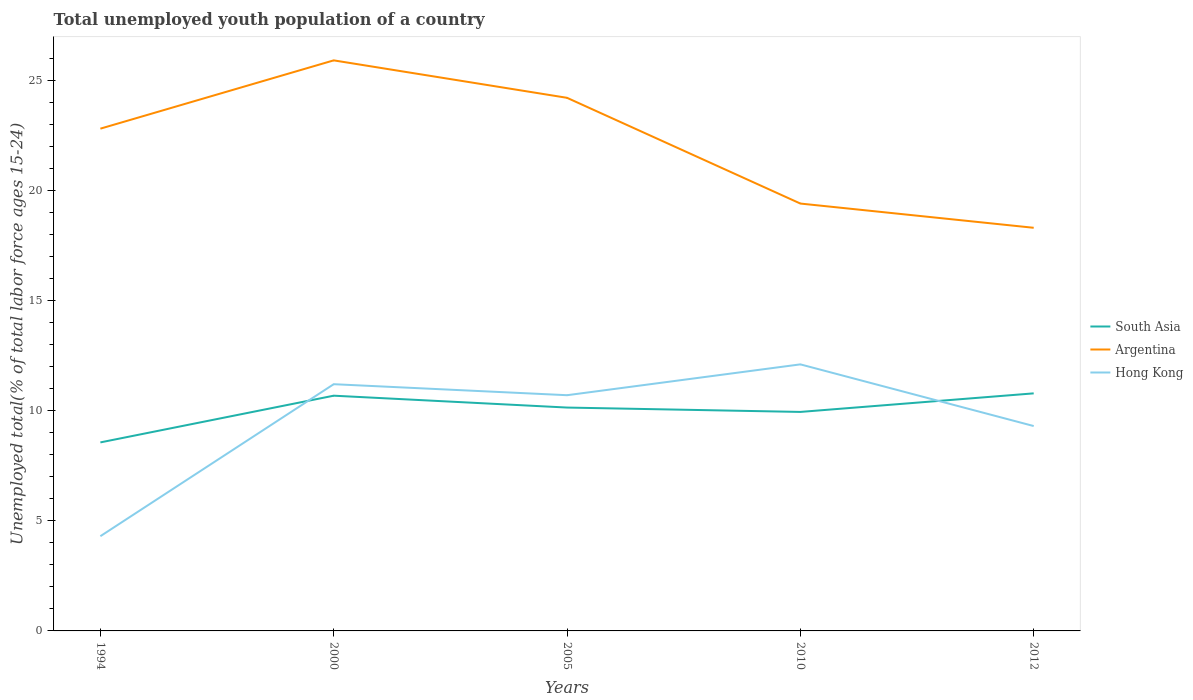Across all years, what is the maximum percentage of total unemployed youth population of a country in South Asia?
Give a very brief answer. 8.56. What is the total percentage of total unemployed youth population of a country in South Asia in the graph?
Make the answer very short. -0.11. What is the difference between the highest and the second highest percentage of total unemployed youth population of a country in Argentina?
Make the answer very short. 7.6. What is the difference between two consecutive major ticks on the Y-axis?
Your response must be concise. 5. Are the values on the major ticks of Y-axis written in scientific E-notation?
Ensure brevity in your answer.  No. Does the graph contain any zero values?
Offer a very short reply. No. What is the title of the graph?
Your answer should be very brief. Total unemployed youth population of a country. Does "Marshall Islands" appear as one of the legend labels in the graph?
Provide a short and direct response. No. What is the label or title of the Y-axis?
Your answer should be compact. Unemployed total(% of total labor force ages 15-24). What is the Unemployed total(% of total labor force ages 15-24) in South Asia in 1994?
Offer a very short reply. 8.56. What is the Unemployed total(% of total labor force ages 15-24) of Argentina in 1994?
Your answer should be compact. 22.8. What is the Unemployed total(% of total labor force ages 15-24) in Hong Kong in 1994?
Provide a succinct answer. 4.3. What is the Unemployed total(% of total labor force ages 15-24) of South Asia in 2000?
Provide a short and direct response. 10.68. What is the Unemployed total(% of total labor force ages 15-24) in Argentina in 2000?
Keep it short and to the point. 25.9. What is the Unemployed total(% of total labor force ages 15-24) of Hong Kong in 2000?
Your response must be concise. 11.2. What is the Unemployed total(% of total labor force ages 15-24) of South Asia in 2005?
Your response must be concise. 10.14. What is the Unemployed total(% of total labor force ages 15-24) of Argentina in 2005?
Ensure brevity in your answer.  24.2. What is the Unemployed total(% of total labor force ages 15-24) in Hong Kong in 2005?
Ensure brevity in your answer.  10.7. What is the Unemployed total(% of total labor force ages 15-24) in South Asia in 2010?
Offer a terse response. 9.94. What is the Unemployed total(% of total labor force ages 15-24) of Argentina in 2010?
Keep it short and to the point. 19.4. What is the Unemployed total(% of total labor force ages 15-24) of Hong Kong in 2010?
Offer a terse response. 12.1. What is the Unemployed total(% of total labor force ages 15-24) of South Asia in 2012?
Offer a very short reply. 10.78. What is the Unemployed total(% of total labor force ages 15-24) in Argentina in 2012?
Your answer should be compact. 18.3. What is the Unemployed total(% of total labor force ages 15-24) of Hong Kong in 2012?
Offer a terse response. 9.3. Across all years, what is the maximum Unemployed total(% of total labor force ages 15-24) in South Asia?
Offer a terse response. 10.78. Across all years, what is the maximum Unemployed total(% of total labor force ages 15-24) in Argentina?
Give a very brief answer. 25.9. Across all years, what is the maximum Unemployed total(% of total labor force ages 15-24) in Hong Kong?
Offer a terse response. 12.1. Across all years, what is the minimum Unemployed total(% of total labor force ages 15-24) in South Asia?
Offer a very short reply. 8.56. Across all years, what is the minimum Unemployed total(% of total labor force ages 15-24) of Argentina?
Keep it short and to the point. 18.3. Across all years, what is the minimum Unemployed total(% of total labor force ages 15-24) of Hong Kong?
Keep it short and to the point. 4.3. What is the total Unemployed total(% of total labor force ages 15-24) of South Asia in the graph?
Keep it short and to the point. 50.1. What is the total Unemployed total(% of total labor force ages 15-24) in Argentina in the graph?
Offer a very short reply. 110.6. What is the total Unemployed total(% of total labor force ages 15-24) of Hong Kong in the graph?
Give a very brief answer. 47.6. What is the difference between the Unemployed total(% of total labor force ages 15-24) of South Asia in 1994 and that in 2000?
Offer a very short reply. -2.12. What is the difference between the Unemployed total(% of total labor force ages 15-24) in South Asia in 1994 and that in 2005?
Ensure brevity in your answer.  -1.58. What is the difference between the Unemployed total(% of total labor force ages 15-24) of Argentina in 1994 and that in 2005?
Your response must be concise. -1.4. What is the difference between the Unemployed total(% of total labor force ages 15-24) in Hong Kong in 1994 and that in 2005?
Your answer should be very brief. -6.4. What is the difference between the Unemployed total(% of total labor force ages 15-24) of South Asia in 1994 and that in 2010?
Your answer should be compact. -1.38. What is the difference between the Unemployed total(% of total labor force ages 15-24) of Argentina in 1994 and that in 2010?
Make the answer very short. 3.4. What is the difference between the Unemployed total(% of total labor force ages 15-24) of South Asia in 1994 and that in 2012?
Your answer should be compact. -2.23. What is the difference between the Unemployed total(% of total labor force ages 15-24) in Hong Kong in 1994 and that in 2012?
Offer a very short reply. -5. What is the difference between the Unemployed total(% of total labor force ages 15-24) of South Asia in 2000 and that in 2005?
Your answer should be very brief. 0.54. What is the difference between the Unemployed total(% of total labor force ages 15-24) in Argentina in 2000 and that in 2005?
Provide a succinct answer. 1.7. What is the difference between the Unemployed total(% of total labor force ages 15-24) in Hong Kong in 2000 and that in 2005?
Offer a terse response. 0.5. What is the difference between the Unemployed total(% of total labor force ages 15-24) of South Asia in 2000 and that in 2010?
Provide a succinct answer. 0.74. What is the difference between the Unemployed total(% of total labor force ages 15-24) of South Asia in 2000 and that in 2012?
Your answer should be very brief. -0.11. What is the difference between the Unemployed total(% of total labor force ages 15-24) in Argentina in 2000 and that in 2012?
Provide a short and direct response. 7.6. What is the difference between the Unemployed total(% of total labor force ages 15-24) in South Asia in 2005 and that in 2010?
Offer a terse response. 0.2. What is the difference between the Unemployed total(% of total labor force ages 15-24) of South Asia in 2005 and that in 2012?
Your answer should be compact. -0.64. What is the difference between the Unemployed total(% of total labor force ages 15-24) of Argentina in 2005 and that in 2012?
Keep it short and to the point. 5.9. What is the difference between the Unemployed total(% of total labor force ages 15-24) in Hong Kong in 2005 and that in 2012?
Offer a terse response. 1.4. What is the difference between the Unemployed total(% of total labor force ages 15-24) in South Asia in 2010 and that in 2012?
Your response must be concise. -0.84. What is the difference between the Unemployed total(% of total labor force ages 15-24) in South Asia in 1994 and the Unemployed total(% of total labor force ages 15-24) in Argentina in 2000?
Ensure brevity in your answer.  -17.34. What is the difference between the Unemployed total(% of total labor force ages 15-24) of South Asia in 1994 and the Unemployed total(% of total labor force ages 15-24) of Hong Kong in 2000?
Make the answer very short. -2.64. What is the difference between the Unemployed total(% of total labor force ages 15-24) of South Asia in 1994 and the Unemployed total(% of total labor force ages 15-24) of Argentina in 2005?
Provide a succinct answer. -15.64. What is the difference between the Unemployed total(% of total labor force ages 15-24) of South Asia in 1994 and the Unemployed total(% of total labor force ages 15-24) of Hong Kong in 2005?
Your answer should be very brief. -2.14. What is the difference between the Unemployed total(% of total labor force ages 15-24) of Argentina in 1994 and the Unemployed total(% of total labor force ages 15-24) of Hong Kong in 2005?
Offer a very short reply. 12.1. What is the difference between the Unemployed total(% of total labor force ages 15-24) in South Asia in 1994 and the Unemployed total(% of total labor force ages 15-24) in Argentina in 2010?
Keep it short and to the point. -10.84. What is the difference between the Unemployed total(% of total labor force ages 15-24) in South Asia in 1994 and the Unemployed total(% of total labor force ages 15-24) in Hong Kong in 2010?
Offer a very short reply. -3.54. What is the difference between the Unemployed total(% of total labor force ages 15-24) of Argentina in 1994 and the Unemployed total(% of total labor force ages 15-24) of Hong Kong in 2010?
Make the answer very short. 10.7. What is the difference between the Unemployed total(% of total labor force ages 15-24) in South Asia in 1994 and the Unemployed total(% of total labor force ages 15-24) in Argentina in 2012?
Provide a short and direct response. -9.74. What is the difference between the Unemployed total(% of total labor force ages 15-24) in South Asia in 1994 and the Unemployed total(% of total labor force ages 15-24) in Hong Kong in 2012?
Provide a short and direct response. -0.74. What is the difference between the Unemployed total(% of total labor force ages 15-24) in South Asia in 2000 and the Unemployed total(% of total labor force ages 15-24) in Argentina in 2005?
Make the answer very short. -13.52. What is the difference between the Unemployed total(% of total labor force ages 15-24) in South Asia in 2000 and the Unemployed total(% of total labor force ages 15-24) in Hong Kong in 2005?
Offer a terse response. -0.02. What is the difference between the Unemployed total(% of total labor force ages 15-24) in South Asia in 2000 and the Unemployed total(% of total labor force ages 15-24) in Argentina in 2010?
Provide a succinct answer. -8.72. What is the difference between the Unemployed total(% of total labor force ages 15-24) of South Asia in 2000 and the Unemployed total(% of total labor force ages 15-24) of Hong Kong in 2010?
Keep it short and to the point. -1.42. What is the difference between the Unemployed total(% of total labor force ages 15-24) in South Asia in 2000 and the Unemployed total(% of total labor force ages 15-24) in Argentina in 2012?
Ensure brevity in your answer.  -7.62. What is the difference between the Unemployed total(% of total labor force ages 15-24) in South Asia in 2000 and the Unemployed total(% of total labor force ages 15-24) in Hong Kong in 2012?
Provide a succinct answer. 1.38. What is the difference between the Unemployed total(% of total labor force ages 15-24) of Argentina in 2000 and the Unemployed total(% of total labor force ages 15-24) of Hong Kong in 2012?
Your answer should be compact. 16.6. What is the difference between the Unemployed total(% of total labor force ages 15-24) in South Asia in 2005 and the Unemployed total(% of total labor force ages 15-24) in Argentina in 2010?
Keep it short and to the point. -9.26. What is the difference between the Unemployed total(% of total labor force ages 15-24) of South Asia in 2005 and the Unemployed total(% of total labor force ages 15-24) of Hong Kong in 2010?
Offer a very short reply. -1.96. What is the difference between the Unemployed total(% of total labor force ages 15-24) of Argentina in 2005 and the Unemployed total(% of total labor force ages 15-24) of Hong Kong in 2010?
Keep it short and to the point. 12.1. What is the difference between the Unemployed total(% of total labor force ages 15-24) in South Asia in 2005 and the Unemployed total(% of total labor force ages 15-24) in Argentina in 2012?
Give a very brief answer. -8.16. What is the difference between the Unemployed total(% of total labor force ages 15-24) of South Asia in 2005 and the Unemployed total(% of total labor force ages 15-24) of Hong Kong in 2012?
Offer a very short reply. 0.84. What is the difference between the Unemployed total(% of total labor force ages 15-24) of South Asia in 2010 and the Unemployed total(% of total labor force ages 15-24) of Argentina in 2012?
Ensure brevity in your answer.  -8.36. What is the difference between the Unemployed total(% of total labor force ages 15-24) in South Asia in 2010 and the Unemployed total(% of total labor force ages 15-24) in Hong Kong in 2012?
Keep it short and to the point. 0.64. What is the average Unemployed total(% of total labor force ages 15-24) of South Asia per year?
Keep it short and to the point. 10.02. What is the average Unemployed total(% of total labor force ages 15-24) of Argentina per year?
Your answer should be very brief. 22.12. What is the average Unemployed total(% of total labor force ages 15-24) of Hong Kong per year?
Provide a succinct answer. 9.52. In the year 1994, what is the difference between the Unemployed total(% of total labor force ages 15-24) in South Asia and Unemployed total(% of total labor force ages 15-24) in Argentina?
Your answer should be very brief. -14.24. In the year 1994, what is the difference between the Unemployed total(% of total labor force ages 15-24) of South Asia and Unemployed total(% of total labor force ages 15-24) of Hong Kong?
Make the answer very short. 4.26. In the year 1994, what is the difference between the Unemployed total(% of total labor force ages 15-24) in Argentina and Unemployed total(% of total labor force ages 15-24) in Hong Kong?
Give a very brief answer. 18.5. In the year 2000, what is the difference between the Unemployed total(% of total labor force ages 15-24) in South Asia and Unemployed total(% of total labor force ages 15-24) in Argentina?
Offer a very short reply. -15.22. In the year 2000, what is the difference between the Unemployed total(% of total labor force ages 15-24) of South Asia and Unemployed total(% of total labor force ages 15-24) of Hong Kong?
Your answer should be compact. -0.52. In the year 2005, what is the difference between the Unemployed total(% of total labor force ages 15-24) of South Asia and Unemployed total(% of total labor force ages 15-24) of Argentina?
Make the answer very short. -14.06. In the year 2005, what is the difference between the Unemployed total(% of total labor force ages 15-24) of South Asia and Unemployed total(% of total labor force ages 15-24) of Hong Kong?
Keep it short and to the point. -0.56. In the year 2005, what is the difference between the Unemployed total(% of total labor force ages 15-24) in Argentina and Unemployed total(% of total labor force ages 15-24) in Hong Kong?
Provide a succinct answer. 13.5. In the year 2010, what is the difference between the Unemployed total(% of total labor force ages 15-24) in South Asia and Unemployed total(% of total labor force ages 15-24) in Argentina?
Make the answer very short. -9.46. In the year 2010, what is the difference between the Unemployed total(% of total labor force ages 15-24) of South Asia and Unemployed total(% of total labor force ages 15-24) of Hong Kong?
Provide a succinct answer. -2.16. In the year 2010, what is the difference between the Unemployed total(% of total labor force ages 15-24) in Argentina and Unemployed total(% of total labor force ages 15-24) in Hong Kong?
Offer a very short reply. 7.3. In the year 2012, what is the difference between the Unemployed total(% of total labor force ages 15-24) in South Asia and Unemployed total(% of total labor force ages 15-24) in Argentina?
Ensure brevity in your answer.  -7.52. In the year 2012, what is the difference between the Unemployed total(% of total labor force ages 15-24) in South Asia and Unemployed total(% of total labor force ages 15-24) in Hong Kong?
Provide a succinct answer. 1.48. What is the ratio of the Unemployed total(% of total labor force ages 15-24) of South Asia in 1994 to that in 2000?
Your answer should be very brief. 0.8. What is the ratio of the Unemployed total(% of total labor force ages 15-24) in Argentina in 1994 to that in 2000?
Give a very brief answer. 0.88. What is the ratio of the Unemployed total(% of total labor force ages 15-24) of Hong Kong in 1994 to that in 2000?
Keep it short and to the point. 0.38. What is the ratio of the Unemployed total(% of total labor force ages 15-24) in South Asia in 1994 to that in 2005?
Offer a very short reply. 0.84. What is the ratio of the Unemployed total(% of total labor force ages 15-24) in Argentina in 1994 to that in 2005?
Your answer should be very brief. 0.94. What is the ratio of the Unemployed total(% of total labor force ages 15-24) in Hong Kong in 1994 to that in 2005?
Provide a succinct answer. 0.4. What is the ratio of the Unemployed total(% of total labor force ages 15-24) in South Asia in 1994 to that in 2010?
Your response must be concise. 0.86. What is the ratio of the Unemployed total(% of total labor force ages 15-24) of Argentina in 1994 to that in 2010?
Your response must be concise. 1.18. What is the ratio of the Unemployed total(% of total labor force ages 15-24) in Hong Kong in 1994 to that in 2010?
Give a very brief answer. 0.36. What is the ratio of the Unemployed total(% of total labor force ages 15-24) in South Asia in 1994 to that in 2012?
Give a very brief answer. 0.79. What is the ratio of the Unemployed total(% of total labor force ages 15-24) in Argentina in 1994 to that in 2012?
Make the answer very short. 1.25. What is the ratio of the Unemployed total(% of total labor force ages 15-24) of Hong Kong in 1994 to that in 2012?
Your answer should be very brief. 0.46. What is the ratio of the Unemployed total(% of total labor force ages 15-24) in South Asia in 2000 to that in 2005?
Your answer should be compact. 1.05. What is the ratio of the Unemployed total(% of total labor force ages 15-24) of Argentina in 2000 to that in 2005?
Offer a very short reply. 1.07. What is the ratio of the Unemployed total(% of total labor force ages 15-24) of Hong Kong in 2000 to that in 2005?
Ensure brevity in your answer.  1.05. What is the ratio of the Unemployed total(% of total labor force ages 15-24) in South Asia in 2000 to that in 2010?
Ensure brevity in your answer.  1.07. What is the ratio of the Unemployed total(% of total labor force ages 15-24) in Argentina in 2000 to that in 2010?
Keep it short and to the point. 1.34. What is the ratio of the Unemployed total(% of total labor force ages 15-24) in Hong Kong in 2000 to that in 2010?
Ensure brevity in your answer.  0.93. What is the ratio of the Unemployed total(% of total labor force ages 15-24) of South Asia in 2000 to that in 2012?
Make the answer very short. 0.99. What is the ratio of the Unemployed total(% of total labor force ages 15-24) of Argentina in 2000 to that in 2012?
Offer a very short reply. 1.42. What is the ratio of the Unemployed total(% of total labor force ages 15-24) of Hong Kong in 2000 to that in 2012?
Offer a terse response. 1.2. What is the ratio of the Unemployed total(% of total labor force ages 15-24) of South Asia in 2005 to that in 2010?
Ensure brevity in your answer.  1.02. What is the ratio of the Unemployed total(% of total labor force ages 15-24) in Argentina in 2005 to that in 2010?
Provide a short and direct response. 1.25. What is the ratio of the Unemployed total(% of total labor force ages 15-24) of Hong Kong in 2005 to that in 2010?
Your answer should be compact. 0.88. What is the ratio of the Unemployed total(% of total labor force ages 15-24) of South Asia in 2005 to that in 2012?
Make the answer very short. 0.94. What is the ratio of the Unemployed total(% of total labor force ages 15-24) of Argentina in 2005 to that in 2012?
Give a very brief answer. 1.32. What is the ratio of the Unemployed total(% of total labor force ages 15-24) of Hong Kong in 2005 to that in 2012?
Your answer should be compact. 1.15. What is the ratio of the Unemployed total(% of total labor force ages 15-24) in South Asia in 2010 to that in 2012?
Keep it short and to the point. 0.92. What is the ratio of the Unemployed total(% of total labor force ages 15-24) in Argentina in 2010 to that in 2012?
Offer a very short reply. 1.06. What is the ratio of the Unemployed total(% of total labor force ages 15-24) in Hong Kong in 2010 to that in 2012?
Ensure brevity in your answer.  1.3. What is the difference between the highest and the second highest Unemployed total(% of total labor force ages 15-24) in South Asia?
Offer a terse response. 0.11. What is the difference between the highest and the second highest Unemployed total(% of total labor force ages 15-24) of Hong Kong?
Provide a succinct answer. 0.9. What is the difference between the highest and the lowest Unemployed total(% of total labor force ages 15-24) in South Asia?
Your answer should be compact. 2.23. 